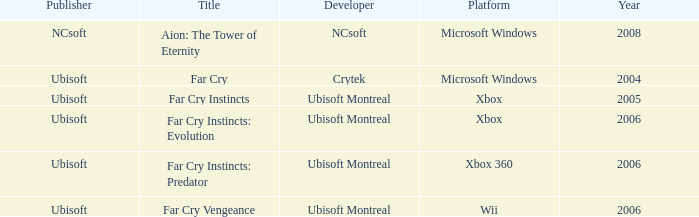Which publisher has Far Cry as the title? Ubisoft. 